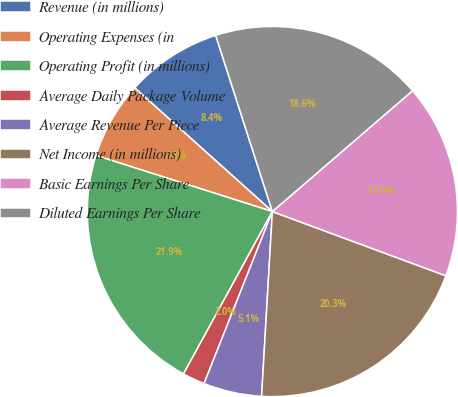<chart> <loc_0><loc_0><loc_500><loc_500><pie_chart><fcel>Revenue (in millions)<fcel>Operating Expenses (in<fcel>Operating Profit (in millions)<fcel>Average Daily Package Volume<fcel>Average Revenue Per Piece<fcel>Net Income (in millions)<fcel>Basic Earnings Per Share<fcel>Diluted Earnings Per Share<nl><fcel>8.4%<fcel>6.75%<fcel>21.93%<fcel>1.95%<fcel>5.09%<fcel>20.28%<fcel>16.97%<fcel>18.63%<nl></chart> 